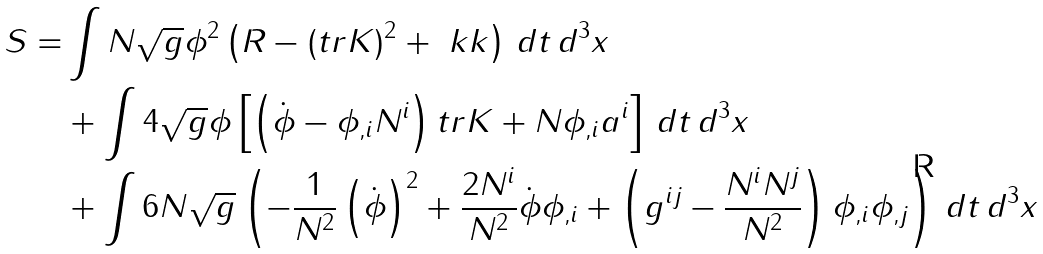<formula> <loc_0><loc_0><loc_500><loc_500>S = & \int N \sqrt { g } \phi ^ { 2 } \left ( R - ( t r K ) ^ { 2 } + \ k k \right ) \, d t \, d ^ { 3 } x \\ & + \int 4 \sqrt { g } \phi \left [ \left ( \dot { \phi } - \phi _ { , i } N ^ { i } \right ) t r K + N \phi _ { , i } a ^ { i } \right ] \, d t \, d ^ { 3 } x \\ & + \int 6 N \sqrt { g } \left ( - \frac { 1 } { N ^ { 2 } } \left ( \dot { \phi } \right ) ^ { 2 } + \frac { 2 N ^ { i } } { N ^ { 2 } } \dot { \phi } \phi _ { , i } + \left ( g ^ { i j } - \frac { N ^ { i } N ^ { j } } { N ^ { 2 } } \right ) \phi _ { , i } \phi _ { , j } \right ) \, d t \, d ^ { 3 } x</formula> 